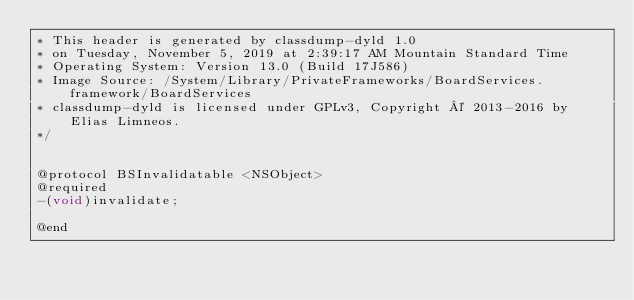Convert code to text. <code><loc_0><loc_0><loc_500><loc_500><_C_>* This header is generated by classdump-dyld 1.0
* on Tuesday, November 5, 2019 at 2:39:17 AM Mountain Standard Time
* Operating System: Version 13.0 (Build 17J586)
* Image Source: /System/Library/PrivateFrameworks/BoardServices.framework/BoardServices
* classdump-dyld is licensed under GPLv3, Copyright © 2013-2016 by Elias Limneos.
*/


@protocol BSInvalidatable <NSObject>
@required
-(void)invalidate;

@end

</code> 